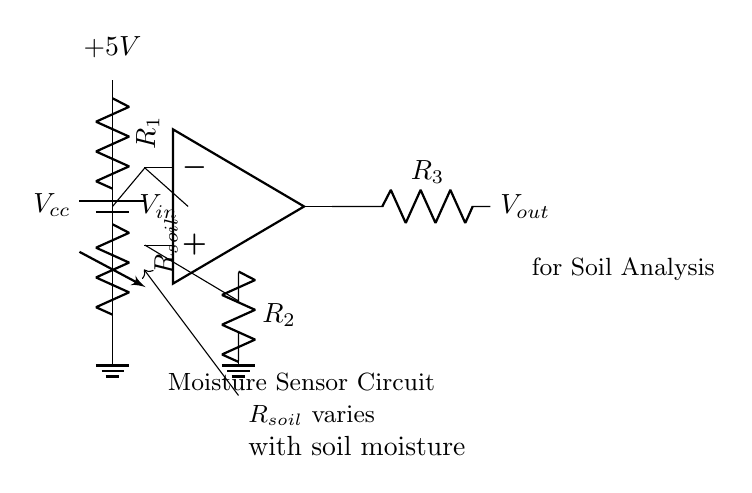What is the operating voltage of the circuit? The circuit is powered by a battery, denoted as $V_{cc}$, which is labeled in the diagram as +5V.
Answer: 5V What is the purpose of the variable resistor in the circuit? The variable resistor, labeled as $R_{soil}$, changes its resistance based on the moisture content of the soil, affecting the input voltage to the op-amp.
Answer: Soil moisture sensor What are the output voltage and its relation to the soil moisture? The output voltage, $V_{out}$, is the result of the op-amp's processing of the input voltage, which varies based on the resistance of $R_{soil}$; thus, $V_{out}$ indicates soil moisture levels.
Answer: Vout varies with moisture Which component receives the input voltage directly from the circuit? The op-amp receives the input voltage directly from the node where $R_{soil}$ and $R_1$ connect, indicated by the line drawn to the negative input of the op-amp.
Answer: Op-amp How does an increase in soil moisture affect the circuit's operation? An increase in soil moisture decreases the resistance of $R_{soil}$, which lowers the input voltage $V_{in}$ to the op-amp; this results in a change in the output voltage, $V_{out}$.
Answer: Increases Vout What is the function of the resistors $R_2$ and $R_3$ in this configuration? Resistors $R_2$ and $R_3$ set the gain of the op-amp and control the output voltage level, respectively, which affects how the moisture signal is processed and output.
Answer: Set gain and output What type of circuit configuration is this? This circuit is an analog sensor circuit designed to measure soil moisture content through resistance changes in the variable resistor.
Answer: Analog sensor circuit 